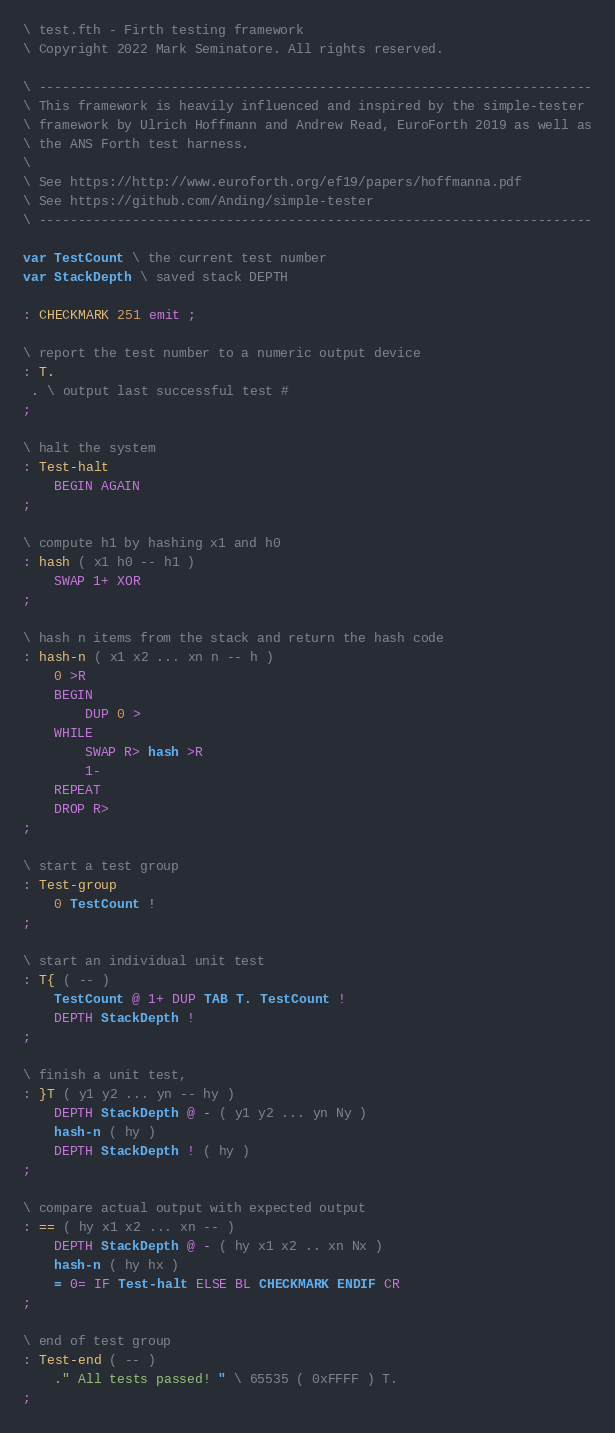Convert code to text. <code><loc_0><loc_0><loc_500><loc_500><_Forth_>\ test.fth - Firth testing framework
\ Copyright 2022 Mark Seminatore. All rights reserved.

\ -----------------------------------------------------------------------
\ This framework is heavily influenced and inspired by the simple-tester 
\ framework by Ulrich Hoffmann and Andrew Read, EuroForth 2019 as well as
\ the ANS Forth test harness.
\
\ See https://http://www.euroforth.org/ef19/papers/hoffmanna.pdf
\ See https://github.com/Anding/simple-tester
\ -----------------------------------------------------------------------

var TestCount \ the current test number
var StackDepth \ saved stack DEPTH

: CHECKMARK 251 emit ;

\ report the test number to a numeric output device
: T.
 . \ output last successful test #
;

\ halt the system
: Test-halt
    BEGIN AGAIN
;

\ compute h1 by hashing x1 and h0
: hash ( x1 h0 -- h1 )
    SWAP 1+ XOR
;

\ hash n items from the stack and return the hash code
: hash-n ( x1 x2 ... xn n -- h )
    0 >R
    BEGIN
        DUP 0 >
    WHILE
        SWAP R> hash >R
        1-
    REPEAT
    DROP R>
;

\ start a test group
: Test-group
    0 TestCount !
;

\ start an individual unit test
: T{ ( -- )
    TestCount @ 1+ DUP TAB T. TestCount ! 
    DEPTH StackDepth !
;

\ finish a unit test,
: }T ( y1 y2 ... yn -- hy )
    DEPTH StackDepth @ - ( y1 y2 ... yn Ny )
    hash-n ( hy )
    DEPTH StackDepth ! ( hy )
;

\ compare actual output with expected output
: == ( hy x1 x2 ... xn -- )
    DEPTH StackDepth @ - ( hy x1 x2 .. xn Nx )
    hash-n ( hy hx )
    = 0= IF Test-halt ELSE BL CHECKMARK ENDIF CR
;

\ end of test group
: Test-end ( -- )
    ." All tests passed! " \ 65535 ( 0xFFFF ) T.
;
</code> 